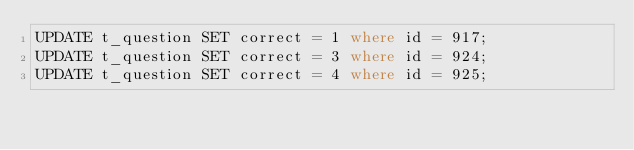<code> <loc_0><loc_0><loc_500><loc_500><_SQL_>UPDATE t_question SET correct = 1 where id = 917;
UPDATE t_question SET correct = 3 where id = 924;
UPDATE t_question SET correct = 4 where id = 925;</code> 